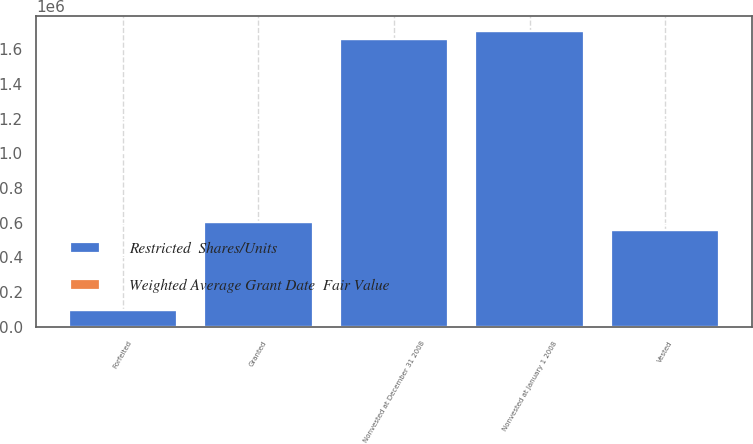Convert chart. <chart><loc_0><loc_0><loc_500><loc_500><stacked_bar_chart><ecel><fcel>Nonvested at January 1 2008<fcel>Granted<fcel>Vested<fcel>Forfeited<fcel>Nonvested at December 31 2008<nl><fcel>Restricted  Shares/Units<fcel>1.70464e+06<fcel>606450<fcel>558281<fcel>95974<fcel>1.65683e+06<nl><fcel>Weighted Average Grant Date  Fair Value<fcel>29.81<fcel>46.22<fcel>26.7<fcel>35.24<fcel>36.56<nl></chart> 